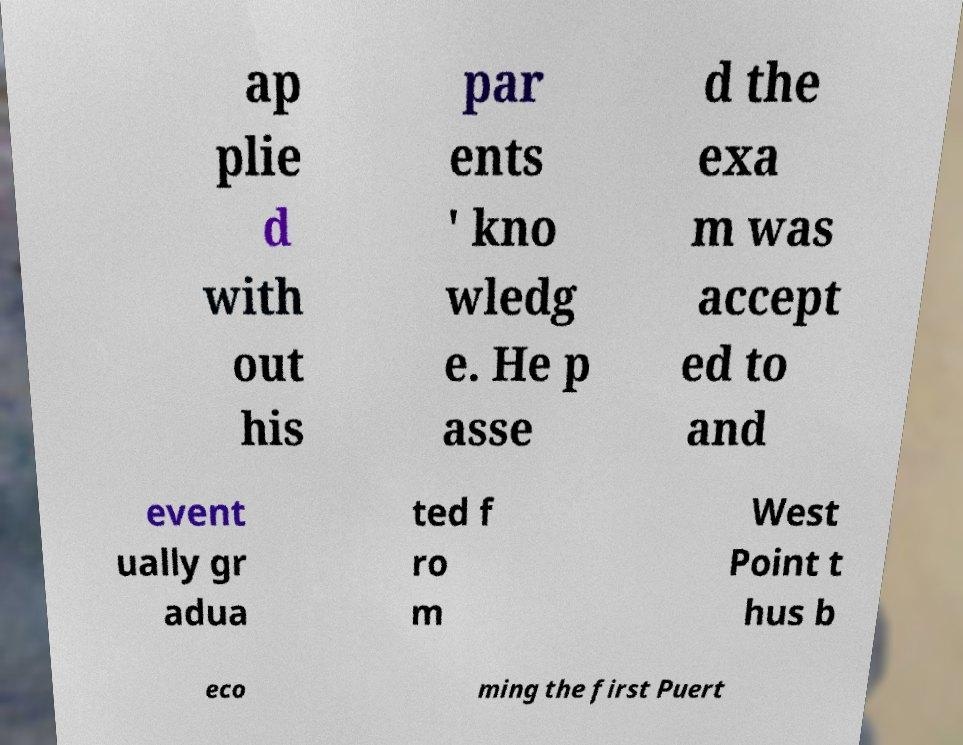I need the written content from this picture converted into text. Can you do that? ap plie d with out his par ents ' kno wledg e. He p asse d the exa m was accept ed to and event ually gr adua ted f ro m West Point t hus b eco ming the first Puert 